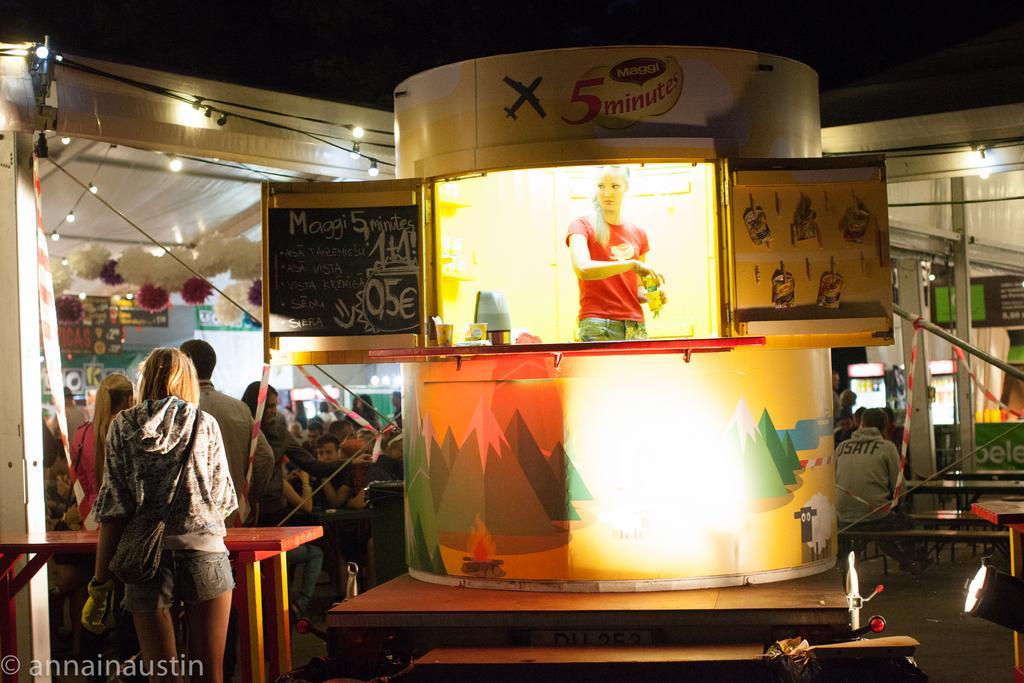Can you describe this image briefly? In this image there are a few stalls with decoration, in front of the stalls there are so many people standing and sitting, there are benches, boards with some text and focus lights. At the center of the image there is a woman holding something in her hand and standing in the stall, in front of her there are so many objects arranged. The background is dark. 